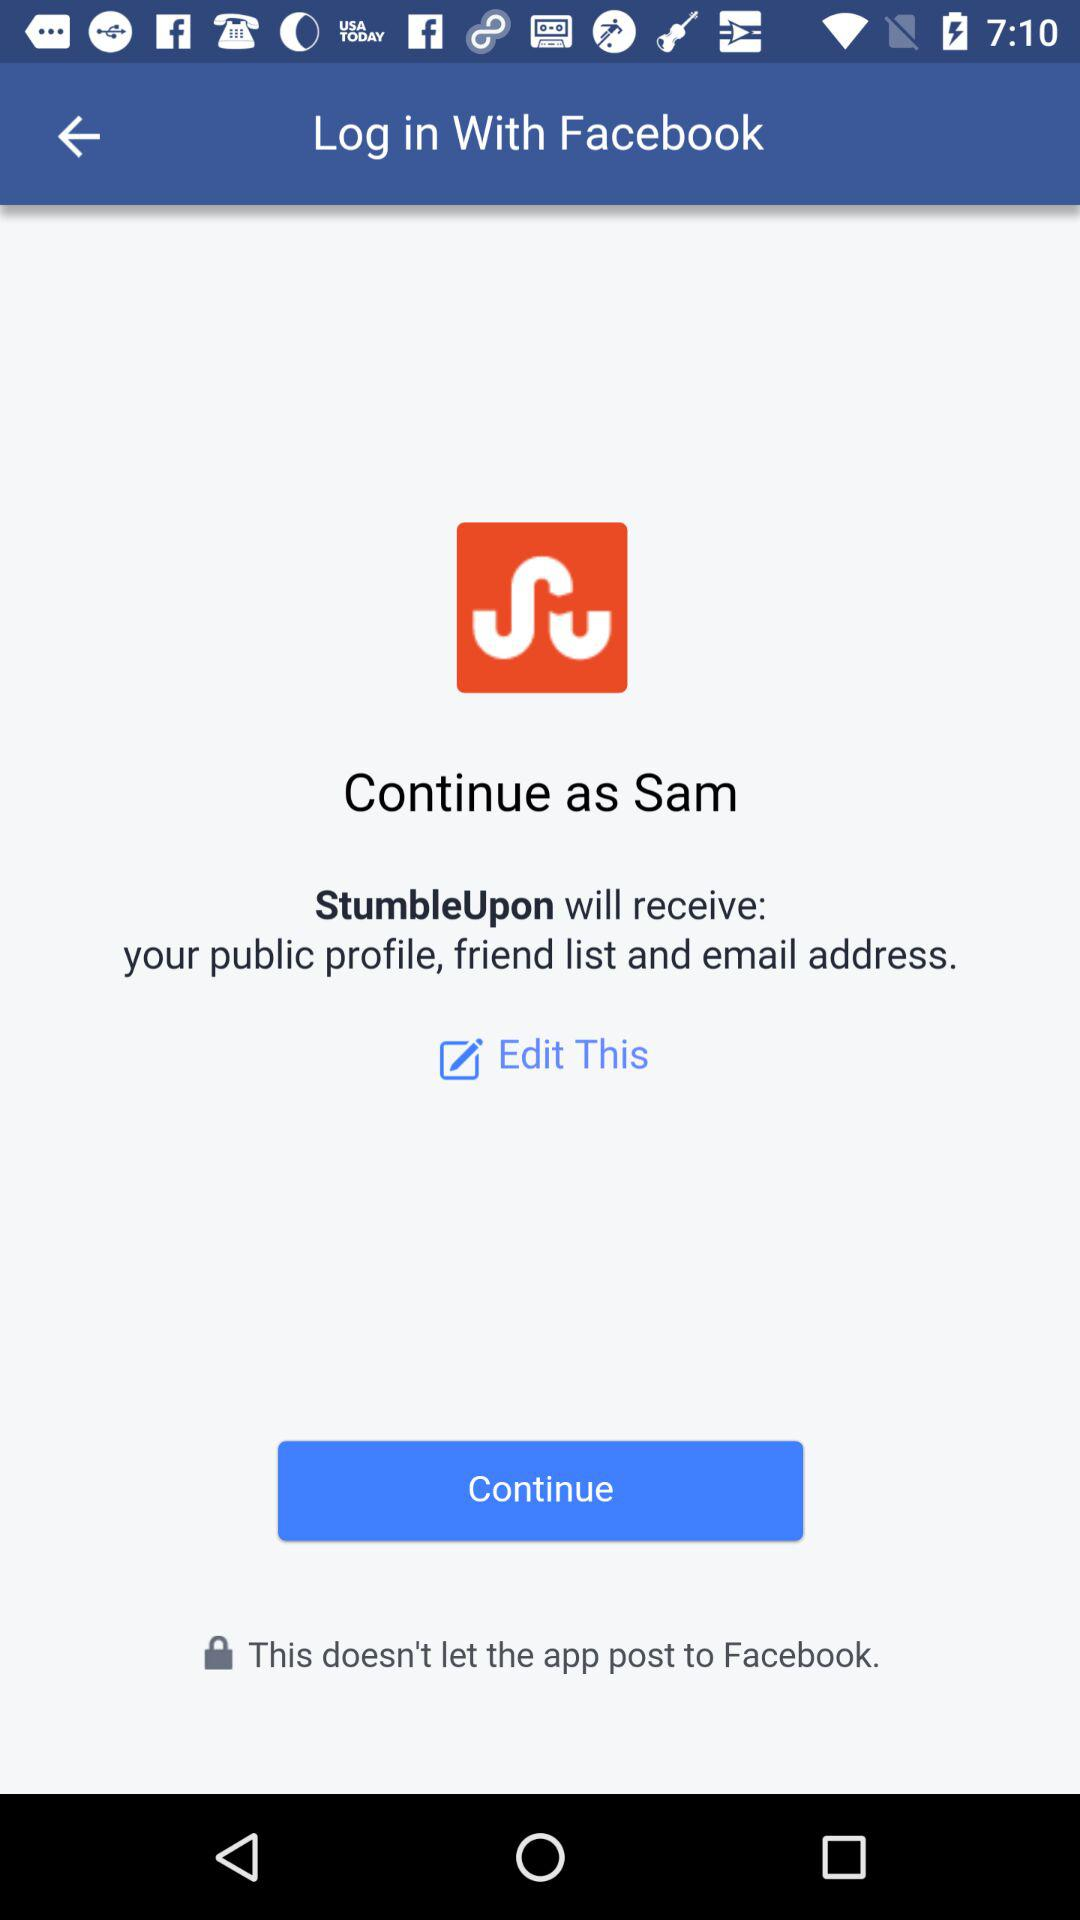What is the user's name? The user's name is Sam. 